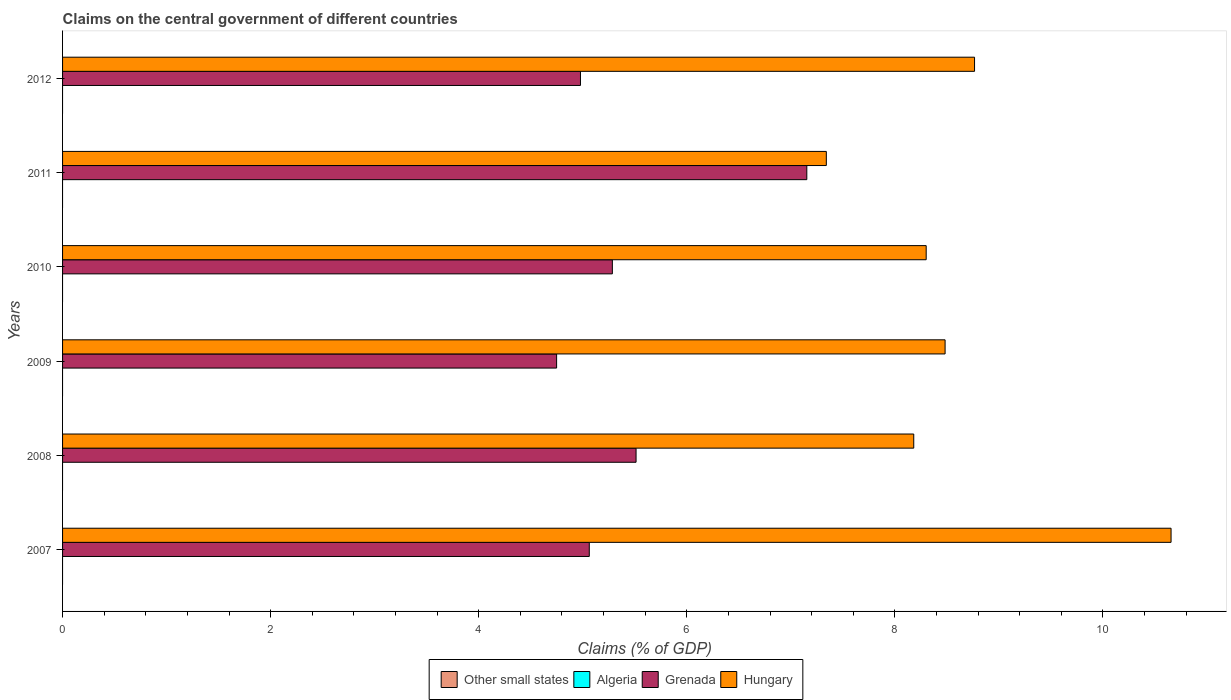How many different coloured bars are there?
Your response must be concise. 2. What is the label of the 5th group of bars from the top?
Your response must be concise. 2008. In how many cases, is the number of bars for a given year not equal to the number of legend labels?
Offer a terse response. 6. What is the percentage of GDP claimed on the central government in Other small states in 2010?
Ensure brevity in your answer.  0. Across all years, what is the maximum percentage of GDP claimed on the central government in Hungary?
Offer a terse response. 10.66. What is the difference between the percentage of GDP claimed on the central government in Grenada in 2009 and that in 2010?
Provide a short and direct response. -0.54. What is the difference between the percentage of GDP claimed on the central government in Other small states in 2010 and the percentage of GDP claimed on the central government in Algeria in 2007?
Give a very brief answer. 0. What is the average percentage of GDP claimed on the central government in Hungary per year?
Offer a terse response. 8.62. In the year 2010, what is the difference between the percentage of GDP claimed on the central government in Hungary and percentage of GDP claimed on the central government in Grenada?
Provide a short and direct response. 3.02. In how many years, is the percentage of GDP claimed on the central government in Algeria greater than 4.4 %?
Make the answer very short. 0. What is the ratio of the percentage of GDP claimed on the central government in Hungary in 2007 to that in 2011?
Your answer should be compact. 1.45. What is the difference between the highest and the second highest percentage of GDP claimed on the central government in Grenada?
Offer a very short reply. 1.64. What is the difference between the highest and the lowest percentage of GDP claimed on the central government in Hungary?
Your response must be concise. 3.31. In how many years, is the percentage of GDP claimed on the central government in Other small states greater than the average percentage of GDP claimed on the central government in Other small states taken over all years?
Give a very brief answer. 0. What is the difference between two consecutive major ticks on the X-axis?
Your answer should be compact. 2. Are the values on the major ticks of X-axis written in scientific E-notation?
Offer a very short reply. No. Where does the legend appear in the graph?
Give a very brief answer. Bottom center. How many legend labels are there?
Make the answer very short. 4. How are the legend labels stacked?
Offer a terse response. Horizontal. What is the title of the graph?
Ensure brevity in your answer.  Claims on the central government of different countries. Does "OECD members" appear as one of the legend labels in the graph?
Your response must be concise. No. What is the label or title of the X-axis?
Offer a terse response. Claims (% of GDP). What is the label or title of the Y-axis?
Keep it short and to the point. Years. What is the Claims (% of GDP) in Grenada in 2007?
Your answer should be compact. 5.06. What is the Claims (% of GDP) in Hungary in 2007?
Your answer should be very brief. 10.66. What is the Claims (% of GDP) in Other small states in 2008?
Your answer should be compact. 0. What is the Claims (% of GDP) in Grenada in 2008?
Your answer should be very brief. 5.51. What is the Claims (% of GDP) in Hungary in 2008?
Make the answer very short. 8.18. What is the Claims (% of GDP) of Algeria in 2009?
Provide a succinct answer. 0. What is the Claims (% of GDP) of Grenada in 2009?
Your answer should be very brief. 4.75. What is the Claims (% of GDP) in Hungary in 2009?
Offer a terse response. 8.48. What is the Claims (% of GDP) of Other small states in 2010?
Give a very brief answer. 0. What is the Claims (% of GDP) of Grenada in 2010?
Your response must be concise. 5.28. What is the Claims (% of GDP) of Hungary in 2010?
Give a very brief answer. 8.3. What is the Claims (% of GDP) of Other small states in 2011?
Offer a very short reply. 0. What is the Claims (% of GDP) of Algeria in 2011?
Provide a succinct answer. 0. What is the Claims (% of GDP) in Grenada in 2011?
Offer a terse response. 7.15. What is the Claims (% of GDP) of Hungary in 2011?
Ensure brevity in your answer.  7.34. What is the Claims (% of GDP) in Other small states in 2012?
Offer a very short reply. 0. What is the Claims (% of GDP) of Grenada in 2012?
Your answer should be very brief. 4.98. What is the Claims (% of GDP) of Hungary in 2012?
Keep it short and to the point. 8.77. Across all years, what is the maximum Claims (% of GDP) in Grenada?
Ensure brevity in your answer.  7.15. Across all years, what is the maximum Claims (% of GDP) in Hungary?
Ensure brevity in your answer.  10.66. Across all years, what is the minimum Claims (% of GDP) of Grenada?
Your response must be concise. 4.75. Across all years, what is the minimum Claims (% of GDP) in Hungary?
Offer a very short reply. 7.34. What is the total Claims (% of GDP) in Grenada in the graph?
Keep it short and to the point. 32.74. What is the total Claims (% of GDP) of Hungary in the graph?
Ensure brevity in your answer.  51.73. What is the difference between the Claims (% of GDP) of Grenada in 2007 and that in 2008?
Offer a very short reply. -0.45. What is the difference between the Claims (% of GDP) in Hungary in 2007 and that in 2008?
Ensure brevity in your answer.  2.47. What is the difference between the Claims (% of GDP) of Grenada in 2007 and that in 2009?
Provide a short and direct response. 0.31. What is the difference between the Claims (% of GDP) in Hungary in 2007 and that in 2009?
Offer a terse response. 2.17. What is the difference between the Claims (% of GDP) of Grenada in 2007 and that in 2010?
Your answer should be compact. -0.22. What is the difference between the Claims (% of GDP) of Hungary in 2007 and that in 2010?
Offer a very short reply. 2.35. What is the difference between the Claims (% of GDP) in Grenada in 2007 and that in 2011?
Ensure brevity in your answer.  -2.09. What is the difference between the Claims (% of GDP) of Hungary in 2007 and that in 2011?
Offer a very short reply. 3.31. What is the difference between the Claims (% of GDP) in Grenada in 2007 and that in 2012?
Provide a short and direct response. 0.08. What is the difference between the Claims (% of GDP) of Hungary in 2007 and that in 2012?
Provide a succinct answer. 1.89. What is the difference between the Claims (% of GDP) of Grenada in 2008 and that in 2009?
Your answer should be very brief. 0.76. What is the difference between the Claims (% of GDP) of Hungary in 2008 and that in 2009?
Provide a short and direct response. -0.3. What is the difference between the Claims (% of GDP) of Grenada in 2008 and that in 2010?
Offer a very short reply. 0.23. What is the difference between the Claims (% of GDP) in Hungary in 2008 and that in 2010?
Keep it short and to the point. -0.12. What is the difference between the Claims (% of GDP) of Grenada in 2008 and that in 2011?
Offer a very short reply. -1.64. What is the difference between the Claims (% of GDP) in Hungary in 2008 and that in 2011?
Your answer should be compact. 0.84. What is the difference between the Claims (% of GDP) in Grenada in 2008 and that in 2012?
Give a very brief answer. 0.53. What is the difference between the Claims (% of GDP) of Hungary in 2008 and that in 2012?
Your answer should be very brief. -0.58. What is the difference between the Claims (% of GDP) of Grenada in 2009 and that in 2010?
Keep it short and to the point. -0.54. What is the difference between the Claims (% of GDP) of Hungary in 2009 and that in 2010?
Provide a succinct answer. 0.18. What is the difference between the Claims (% of GDP) in Grenada in 2009 and that in 2011?
Make the answer very short. -2.4. What is the difference between the Claims (% of GDP) in Hungary in 2009 and that in 2011?
Give a very brief answer. 1.14. What is the difference between the Claims (% of GDP) in Grenada in 2009 and that in 2012?
Offer a very short reply. -0.23. What is the difference between the Claims (% of GDP) in Hungary in 2009 and that in 2012?
Give a very brief answer. -0.28. What is the difference between the Claims (% of GDP) of Grenada in 2010 and that in 2011?
Provide a short and direct response. -1.87. What is the difference between the Claims (% of GDP) of Hungary in 2010 and that in 2011?
Make the answer very short. 0.96. What is the difference between the Claims (% of GDP) in Grenada in 2010 and that in 2012?
Offer a very short reply. 0.31. What is the difference between the Claims (% of GDP) in Hungary in 2010 and that in 2012?
Your response must be concise. -0.46. What is the difference between the Claims (% of GDP) in Grenada in 2011 and that in 2012?
Make the answer very short. 2.18. What is the difference between the Claims (% of GDP) of Hungary in 2011 and that in 2012?
Your answer should be very brief. -1.42. What is the difference between the Claims (% of GDP) in Grenada in 2007 and the Claims (% of GDP) in Hungary in 2008?
Provide a succinct answer. -3.12. What is the difference between the Claims (% of GDP) of Grenada in 2007 and the Claims (% of GDP) of Hungary in 2009?
Make the answer very short. -3.42. What is the difference between the Claims (% of GDP) of Grenada in 2007 and the Claims (% of GDP) of Hungary in 2010?
Keep it short and to the point. -3.24. What is the difference between the Claims (% of GDP) in Grenada in 2007 and the Claims (% of GDP) in Hungary in 2011?
Ensure brevity in your answer.  -2.28. What is the difference between the Claims (% of GDP) in Grenada in 2007 and the Claims (% of GDP) in Hungary in 2012?
Your answer should be compact. -3.7. What is the difference between the Claims (% of GDP) in Grenada in 2008 and the Claims (% of GDP) in Hungary in 2009?
Keep it short and to the point. -2.97. What is the difference between the Claims (% of GDP) in Grenada in 2008 and the Claims (% of GDP) in Hungary in 2010?
Your response must be concise. -2.79. What is the difference between the Claims (% of GDP) in Grenada in 2008 and the Claims (% of GDP) in Hungary in 2011?
Offer a terse response. -1.83. What is the difference between the Claims (% of GDP) of Grenada in 2008 and the Claims (% of GDP) of Hungary in 2012?
Provide a succinct answer. -3.25. What is the difference between the Claims (% of GDP) of Grenada in 2009 and the Claims (% of GDP) of Hungary in 2010?
Ensure brevity in your answer.  -3.55. What is the difference between the Claims (% of GDP) in Grenada in 2009 and the Claims (% of GDP) in Hungary in 2011?
Keep it short and to the point. -2.59. What is the difference between the Claims (% of GDP) of Grenada in 2009 and the Claims (% of GDP) of Hungary in 2012?
Your response must be concise. -4.02. What is the difference between the Claims (% of GDP) in Grenada in 2010 and the Claims (% of GDP) in Hungary in 2011?
Provide a succinct answer. -2.06. What is the difference between the Claims (% of GDP) in Grenada in 2010 and the Claims (% of GDP) in Hungary in 2012?
Make the answer very short. -3.48. What is the difference between the Claims (% of GDP) of Grenada in 2011 and the Claims (% of GDP) of Hungary in 2012?
Offer a very short reply. -1.61. What is the average Claims (% of GDP) of Algeria per year?
Offer a terse response. 0. What is the average Claims (% of GDP) in Grenada per year?
Your response must be concise. 5.46. What is the average Claims (% of GDP) of Hungary per year?
Offer a very short reply. 8.62. In the year 2007, what is the difference between the Claims (% of GDP) in Grenada and Claims (% of GDP) in Hungary?
Keep it short and to the point. -5.59. In the year 2008, what is the difference between the Claims (% of GDP) in Grenada and Claims (% of GDP) in Hungary?
Your answer should be very brief. -2.67. In the year 2009, what is the difference between the Claims (% of GDP) in Grenada and Claims (% of GDP) in Hungary?
Make the answer very short. -3.73. In the year 2010, what is the difference between the Claims (% of GDP) in Grenada and Claims (% of GDP) in Hungary?
Offer a very short reply. -3.02. In the year 2011, what is the difference between the Claims (% of GDP) in Grenada and Claims (% of GDP) in Hungary?
Make the answer very short. -0.19. In the year 2012, what is the difference between the Claims (% of GDP) in Grenada and Claims (% of GDP) in Hungary?
Offer a terse response. -3.79. What is the ratio of the Claims (% of GDP) of Grenada in 2007 to that in 2008?
Your response must be concise. 0.92. What is the ratio of the Claims (% of GDP) of Hungary in 2007 to that in 2008?
Give a very brief answer. 1.3. What is the ratio of the Claims (% of GDP) of Grenada in 2007 to that in 2009?
Ensure brevity in your answer.  1.07. What is the ratio of the Claims (% of GDP) in Hungary in 2007 to that in 2009?
Offer a very short reply. 1.26. What is the ratio of the Claims (% of GDP) of Grenada in 2007 to that in 2010?
Make the answer very short. 0.96. What is the ratio of the Claims (% of GDP) in Hungary in 2007 to that in 2010?
Your response must be concise. 1.28. What is the ratio of the Claims (% of GDP) in Grenada in 2007 to that in 2011?
Provide a succinct answer. 0.71. What is the ratio of the Claims (% of GDP) in Hungary in 2007 to that in 2011?
Provide a short and direct response. 1.45. What is the ratio of the Claims (% of GDP) in Hungary in 2007 to that in 2012?
Offer a terse response. 1.22. What is the ratio of the Claims (% of GDP) of Grenada in 2008 to that in 2009?
Provide a short and direct response. 1.16. What is the ratio of the Claims (% of GDP) in Hungary in 2008 to that in 2009?
Provide a short and direct response. 0.96. What is the ratio of the Claims (% of GDP) in Grenada in 2008 to that in 2010?
Offer a very short reply. 1.04. What is the ratio of the Claims (% of GDP) in Hungary in 2008 to that in 2010?
Keep it short and to the point. 0.99. What is the ratio of the Claims (% of GDP) in Grenada in 2008 to that in 2011?
Your answer should be compact. 0.77. What is the ratio of the Claims (% of GDP) of Hungary in 2008 to that in 2011?
Your answer should be compact. 1.11. What is the ratio of the Claims (% of GDP) of Grenada in 2008 to that in 2012?
Your answer should be very brief. 1.11. What is the ratio of the Claims (% of GDP) of Grenada in 2009 to that in 2010?
Offer a very short reply. 0.9. What is the ratio of the Claims (% of GDP) in Hungary in 2009 to that in 2010?
Ensure brevity in your answer.  1.02. What is the ratio of the Claims (% of GDP) of Grenada in 2009 to that in 2011?
Provide a succinct answer. 0.66. What is the ratio of the Claims (% of GDP) in Hungary in 2009 to that in 2011?
Your answer should be compact. 1.16. What is the ratio of the Claims (% of GDP) of Grenada in 2009 to that in 2012?
Provide a short and direct response. 0.95. What is the ratio of the Claims (% of GDP) of Grenada in 2010 to that in 2011?
Offer a very short reply. 0.74. What is the ratio of the Claims (% of GDP) of Hungary in 2010 to that in 2011?
Keep it short and to the point. 1.13. What is the ratio of the Claims (% of GDP) of Grenada in 2010 to that in 2012?
Give a very brief answer. 1.06. What is the ratio of the Claims (% of GDP) in Hungary in 2010 to that in 2012?
Offer a terse response. 0.95. What is the ratio of the Claims (% of GDP) of Grenada in 2011 to that in 2012?
Provide a short and direct response. 1.44. What is the ratio of the Claims (% of GDP) of Hungary in 2011 to that in 2012?
Ensure brevity in your answer.  0.84. What is the difference between the highest and the second highest Claims (% of GDP) in Grenada?
Your answer should be very brief. 1.64. What is the difference between the highest and the second highest Claims (% of GDP) in Hungary?
Make the answer very short. 1.89. What is the difference between the highest and the lowest Claims (% of GDP) in Grenada?
Offer a very short reply. 2.4. What is the difference between the highest and the lowest Claims (% of GDP) of Hungary?
Provide a succinct answer. 3.31. 